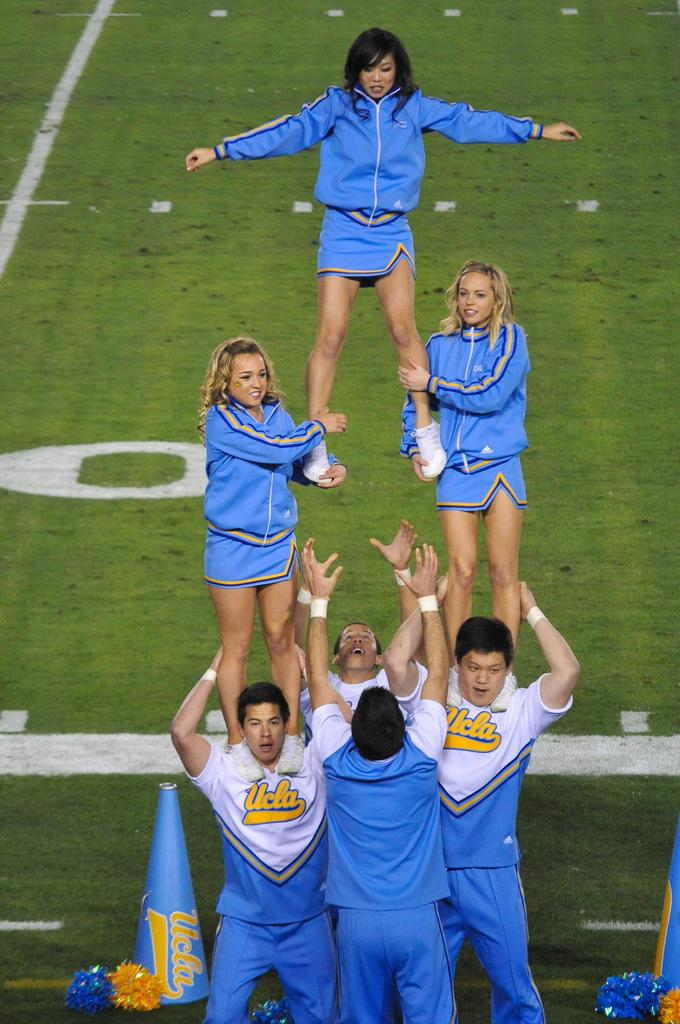Provide a one-sentence caption for the provided image. A group of UCLA cheerleaders attempt to pull off a difficult routine. 